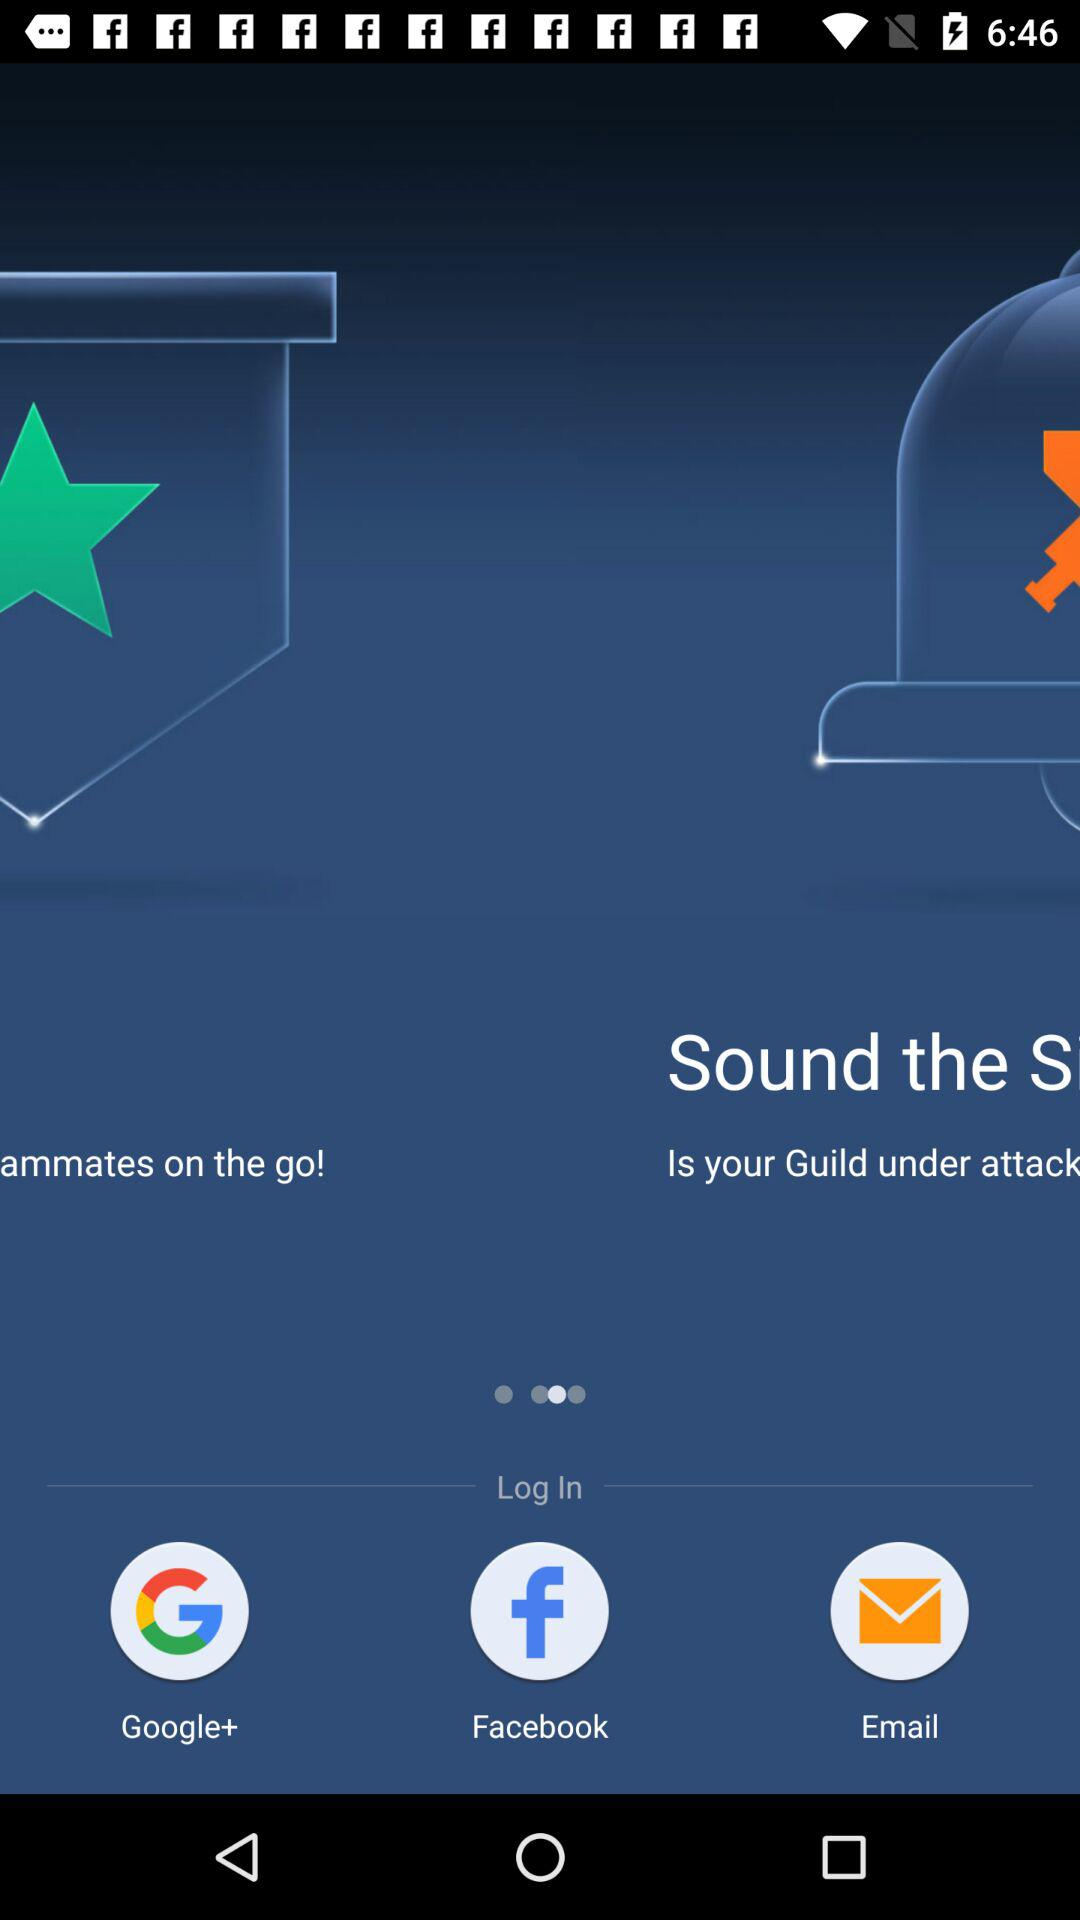Through which application can we log in? You can log in through "Google+" and "Facebook". 